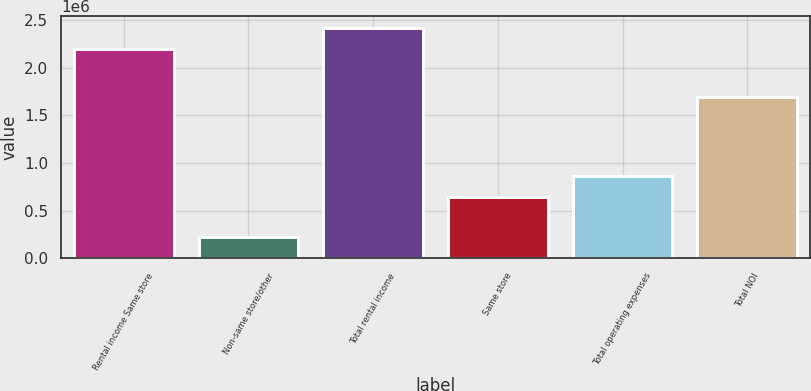Convert chart to OTSL. <chart><loc_0><loc_0><loc_500><loc_500><bar_chart><fcel>Rental income Same store<fcel>Non-same store/other<fcel>Total rental income<fcel>Same store<fcel>Total operating expenses<fcel>Total NOI<nl><fcel>2.20009e+06<fcel>222139<fcel>2.42223e+06<fcel>639342<fcel>859351<fcel>1.69802e+06<nl></chart> 